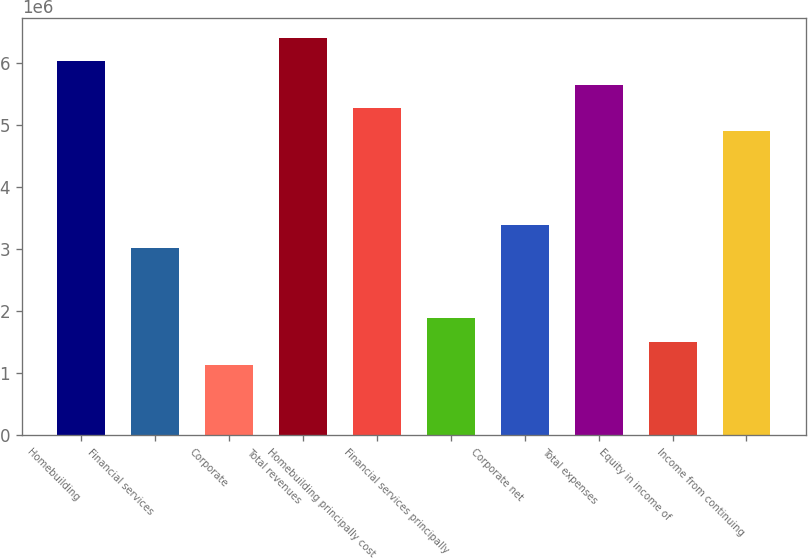<chart> <loc_0><loc_0><loc_500><loc_500><bar_chart><fcel>Homebuilding<fcel>Financial services<fcel>Corporate<fcel>Total revenues<fcel>Homebuilding principally cost<fcel>Financial services principally<fcel>Corporate net<fcel>Total expenses<fcel>Equity in income of<fcel>Income from continuing<nl><fcel>6.02211e+06<fcel>3.01105e+06<fcel>1.12915e+06<fcel>6.39849e+06<fcel>5.26934e+06<fcel>1.88191e+06<fcel>3.38744e+06<fcel>5.64573e+06<fcel>1.50553e+06<fcel>4.89296e+06<nl></chart> 